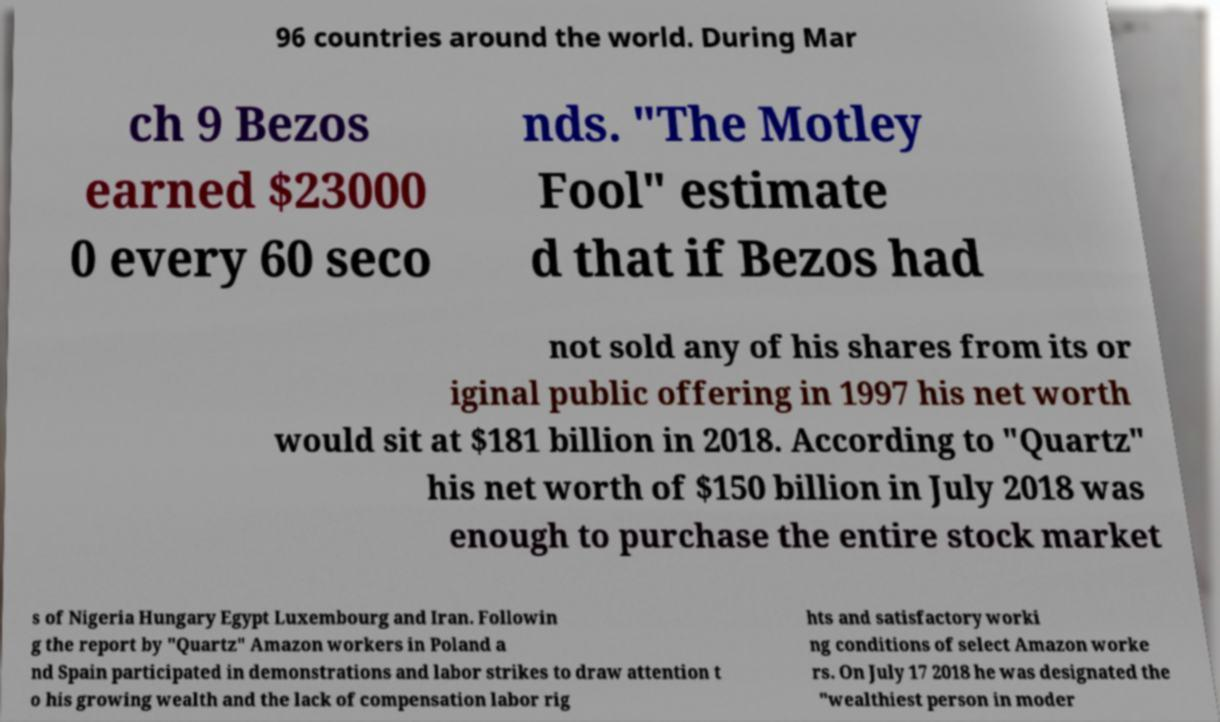Could you assist in decoding the text presented in this image and type it out clearly? 96 countries around the world. During Mar ch 9 Bezos earned $23000 0 every 60 seco nds. "The Motley Fool" estimate d that if Bezos had not sold any of his shares from its or iginal public offering in 1997 his net worth would sit at $181 billion in 2018. According to "Quartz" his net worth of $150 billion in July 2018 was enough to purchase the entire stock market s of Nigeria Hungary Egypt Luxembourg and Iran. Followin g the report by "Quartz" Amazon workers in Poland a nd Spain participated in demonstrations and labor strikes to draw attention t o his growing wealth and the lack of compensation labor rig hts and satisfactory worki ng conditions of select Amazon worke rs. On July 17 2018 he was designated the "wealthiest person in moder 